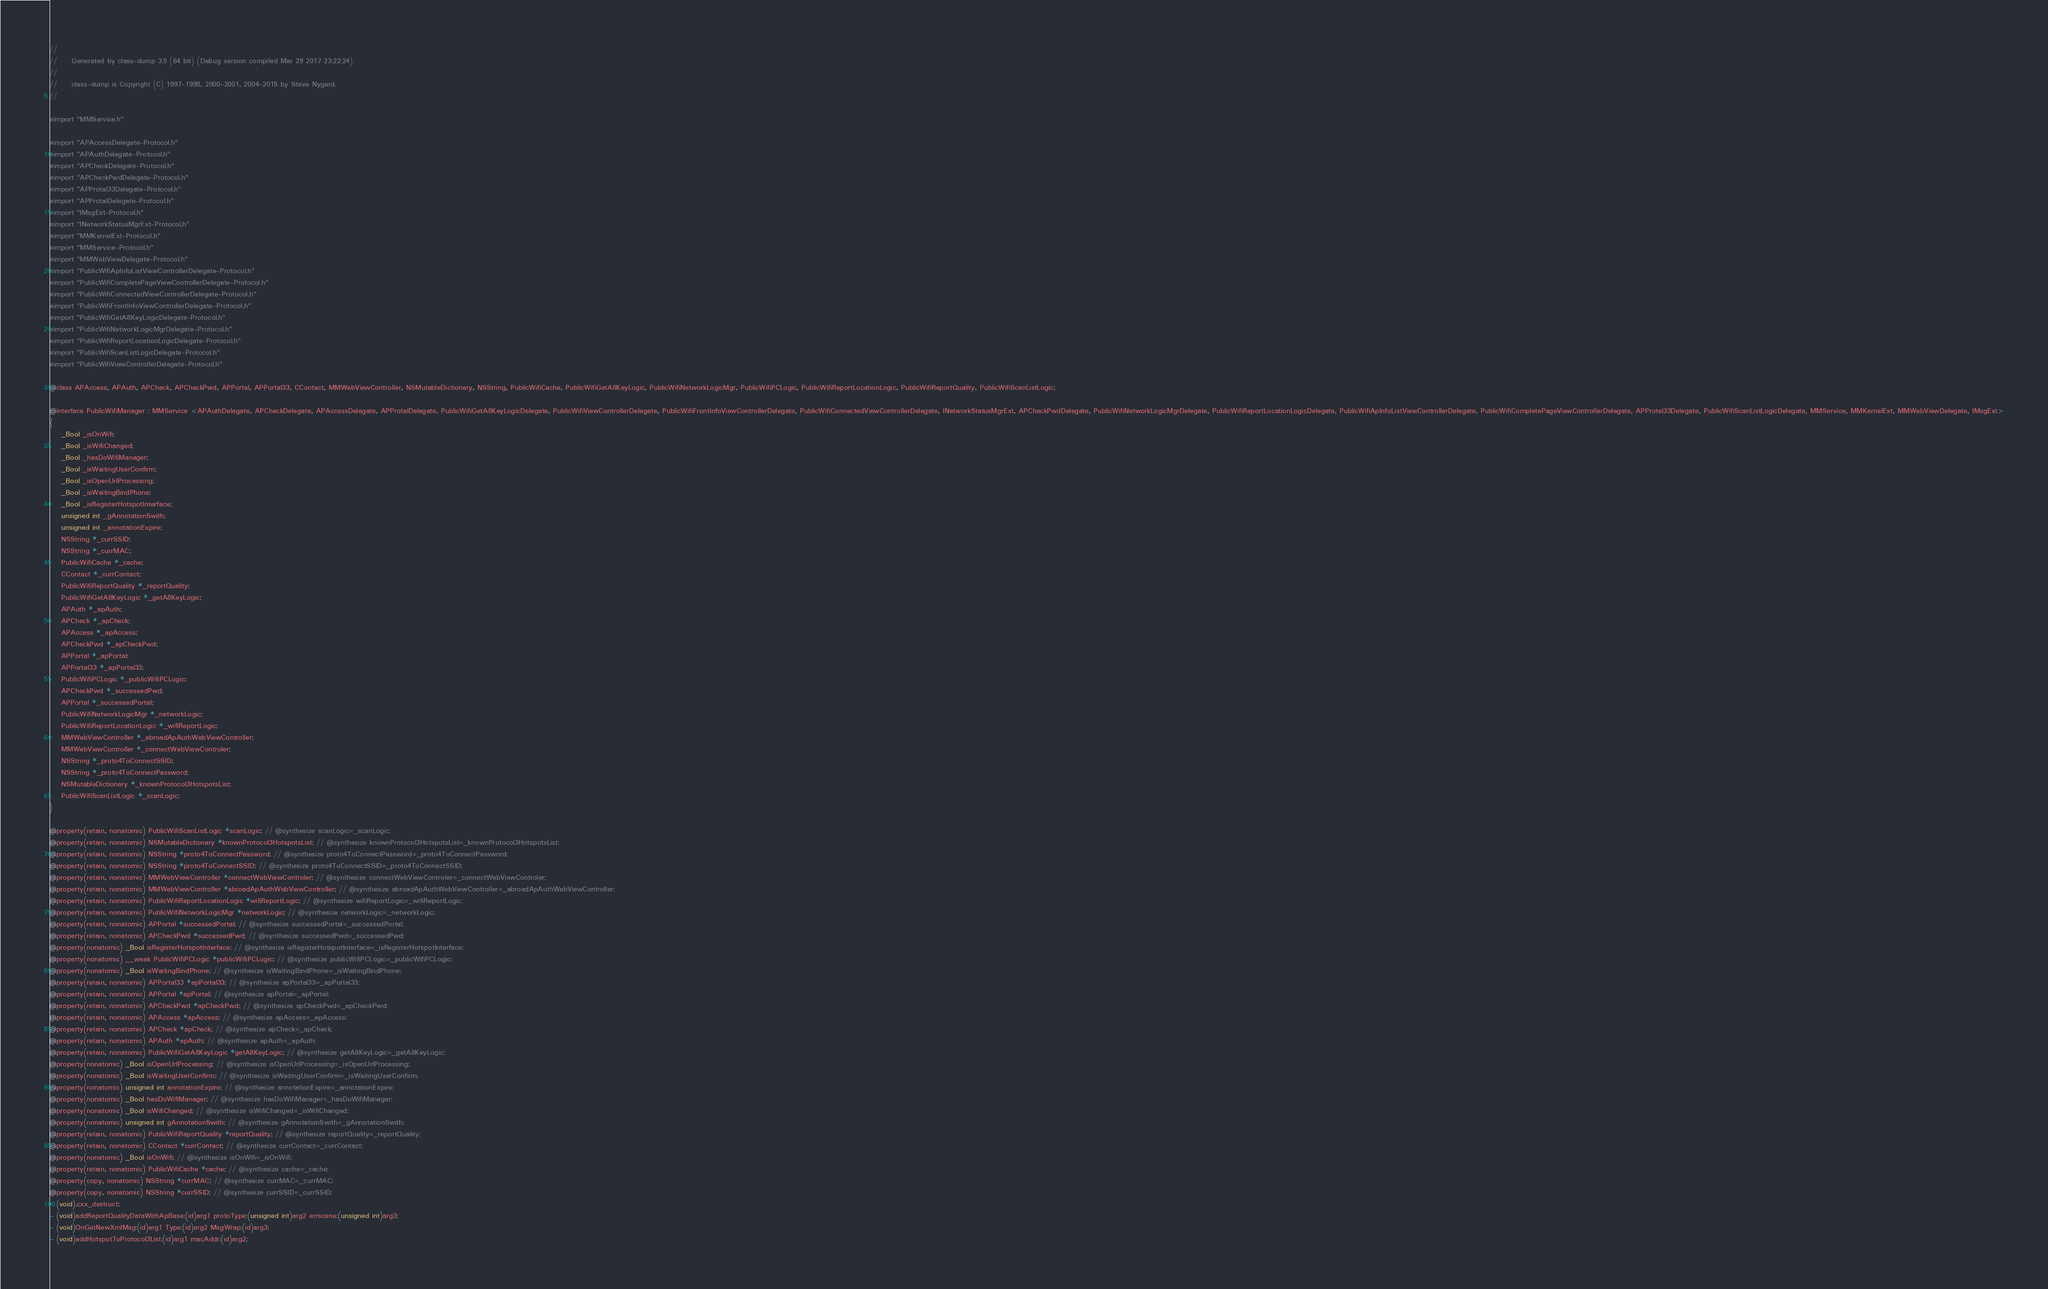<code> <loc_0><loc_0><loc_500><loc_500><_C_>//
//     Generated by class-dump 3.5 (64 bit) (Debug version compiled Mar 29 2017 23:22:24).
//
//     class-dump is Copyright (C) 1997-1998, 2000-2001, 2004-2015 by Steve Nygard.
//

#import "MMService.h"

#import "APAccessDelegate-Protocol.h"
#import "APAuthDelegate-Protocol.h"
#import "APCheckDelegate-Protocol.h"
#import "APCheckPwdDelegate-Protocol.h"
#import "APProtal33Delegate-Protocol.h"
#import "APProtalDelegate-Protocol.h"
#import "IMsgExt-Protocol.h"
#import "INetworkStatusMgrExt-Protocol.h"
#import "MMKernelExt-Protocol.h"
#import "MMService-Protocol.h"
#import "MMWebViewDelegate-Protocol.h"
#import "PublicWifiApInfoListViewControllerDelegate-Protocol.h"
#import "PublicWifiCompletePageViewControllerDelegate-Protocol.h"
#import "PublicWifiConnectedViewControllerDelegate-Protocol.h"
#import "PublicWifiFrontInfoViewControllerDelegate-Protocol.h"
#import "PublicWifiGetA8KeyLogicDelegate-Protocol.h"
#import "PublicWifiNetworkLogicMgrDelegate-Protocol.h"
#import "PublicWifiReportLocationLogicDelegate-Protocol.h"
#import "PublicWifiScanListLogicDelegate-Protocol.h"
#import "PublicWifiViewControllerDelegate-Protocol.h"

@class APAccess, APAuth, APCheck, APCheckPwd, APPortal, APPortal33, CContact, MMWebViewController, NSMutableDictionary, NSString, PublicWifiCache, PublicWifiGetA8KeyLogic, PublicWifiNetworkLogicMgr, PublicWifiPCLogic, PublicWifiReportLocationLogic, PublicWifiReportQuality, PublicWifiScanListLogic;

@interface PublicWifiManager : MMService <APAuthDelegate, APCheckDelegate, APAccessDelegate, APProtalDelegate, PublicWifiGetA8KeyLogicDelegate, PublicWifiViewControllerDelegate, PublicWifiFrontInfoViewControllerDelegate, PublicWifiConnectedViewControllerDelegate, INetworkStatusMgrExt, APCheckPwdDelegate, PublicWifiNetworkLogicMgrDelegate, PublicWifiReportLocationLogicDelegate, PublicWifiApInfoListViewControllerDelegate, PublicWifiCompletePageViewControllerDelegate, APProtal33Delegate, PublicWifiScanListLogicDelegate, MMService, MMKernelExt, MMWebViewDelegate, IMsgExt>
{
    _Bool _isOnWifi;
    _Bool _isWifiChanged;
    _Bool _hasDoWifiManager;
    _Bool _isWaitingUserConfirm;
    _Bool _isOpenUrlProcessing;
    _Bool _isWaitingBindPhone;
    _Bool _isRegisterHotspotInterface;
    unsigned int _gAnnotationSwith;
    unsigned int _annotationExpire;
    NSString *_currSSID;
    NSString *_currMAC;
    PublicWifiCache *_cache;
    CContact *_currContact;
    PublicWifiReportQuality *_reportQuality;
    PublicWifiGetA8KeyLogic *_getA8KeyLogic;
    APAuth *_apAuth;
    APCheck *_apCheck;
    APAccess *_apAccess;
    APCheckPwd *_apCheckPwd;
    APPortal *_apPortal;
    APPortal33 *_apPortal33;
    PublicWifiPCLogic *_publicWifiPCLogic;
    APCheckPwd *_successedPwd;
    APPortal *_successedPortal;
    PublicWifiNetworkLogicMgr *_networkLogic;
    PublicWifiReportLocationLogic *_wifiReportLogic;
    MMWebViewController *_abroadApAuthWebViewController;
    MMWebViewController *_connectWebViewControler;
    NSString *_proto4ToConnectSSID;
    NSString *_proto4ToConnectPassword;
    NSMutableDictionary *_knownProtocol3HotspotsList;
    PublicWifiScanListLogic *_scanLogic;
}

@property(retain, nonatomic) PublicWifiScanListLogic *scanLogic; // @synthesize scanLogic=_scanLogic;
@property(retain, nonatomic) NSMutableDictionary *knownProtocol3HotspotsList; // @synthesize knownProtocol3HotspotsList=_knownProtocol3HotspotsList;
@property(retain, nonatomic) NSString *proto4ToConnectPassword; // @synthesize proto4ToConnectPassword=_proto4ToConnectPassword;
@property(retain, nonatomic) NSString *proto4ToConnectSSID; // @synthesize proto4ToConnectSSID=_proto4ToConnectSSID;
@property(retain, nonatomic) MMWebViewController *connectWebViewControler; // @synthesize connectWebViewControler=_connectWebViewControler;
@property(retain, nonatomic) MMWebViewController *abroadApAuthWebViewController; // @synthesize abroadApAuthWebViewController=_abroadApAuthWebViewController;
@property(retain, nonatomic) PublicWifiReportLocationLogic *wifiReportLogic; // @synthesize wifiReportLogic=_wifiReportLogic;
@property(retain, nonatomic) PublicWifiNetworkLogicMgr *networkLogic; // @synthesize networkLogic=_networkLogic;
@property(retain, nonatomic) APPortal *successedPortal; // @synthesize successedPortal=_successedPortal;
@property(retain, nonatomic) APCheckPwd *successedPwd; // @synthesize successedPwd=_successedPwd;
@property(nonatomic) _Bool isRegisterHotspotInterface; // @synthesize isRegisterHotspotInterface=_isRegisterHotspotInterface;
@property(nonatomic) __weak PublicWifiPCLogic *publicWifiPCLogic; // @synthesize publicWifiPCLogic=_publicWifiPCLogic;
@property(nonatomic) _Bool isWaitingBindPhone; // @synthesize isWaitingBindPhone=_isWaitingBindPhone;
@property(retain, nonatomic) APPortal33 *apPortal33; // @synthesize apPortal33=_apPortal33;
@property(retain, nonatomic) APPortal *apPortal; // @synthesize apPortal=_apPortal;
@property(retain, nonatomic) APCheckPwd *apCheckPwd; // @synthesize apCheckPwd=_apCheckPwd;
@property(retain, nonatomic) APAccess *apAccess; // @synthesize apAccess=_apAccess;
@property(retain, nonatomic) APCheck *apCheck; // @synthesize apCheck=_apCheck;
@property(retain, nonatomic) APAuth *apAuth; // @synthesize apAuth=_apAuth;
@property(retain, nonatomic) PublicWifiGetA8KeyLogic *getA8KeyLogic; // @synthesize getA8KeyLogic=_getA8KeyLogic;
@property(nonatomic) _Bool isOpenUrlProcessing; // @synthesize isOpenUrlProcessing=_isOpenUrlProcessing;
@property(nonatomic) _Bool isWaitingUserConfirm; // @synthesize isWaitingUserConfirm=_isWaitingUserConfirm;
@property(nonatomic) unsigned int annotationExpire; // @synthesize annotationExpire=_annotationExpire;
@property(nonatomic) _Bool hasDoWifiManager; // @synthesize hasDoWifiManager=_hasDoWifiManager;
@property(nonatomic) _Bool isWifiChanged; // @synthesize isWifiChanged=_isWifiChanged;
@property(nonatomic) unsigned int gAnnotationSwith; // @synthesize gAnnotationSwith=_gAnnotationSwith;
@property(retain, nonatomic) PublicWifiReportQuality *reportQuality; // @synthesize reportQuality=_reportQuality;
@property(retain, nonatomic) CContact *currContact; // @synthesize currContact=_currContact;
@property(nonatomic) _Bool isOnWifi; // @synthesize isOnWifi=_isOnWifi;
@property(retain, nonatomic) PublicWifiCache *cache; // @synthesize cache=_cache;
@property(copy, nonatomic) NSString *currMAC; // @synthesize currMAC=_currMAC;
@property(copy, nonatomic) NSString *currSSID; // @synthesize currSSID=_currSSID;
- (void).cxx_destruct;
- (void)addReportQualityDataWithApBase:(id)arg1 protoType:(unsigned int)arg2 errscene:(unsigned int)arg3;
- (void)OnGetNewXmlMsg:(id)arg1 Type:(id)arg2 MsgWrap:(id)arg3;
- (void)addHotspotToProtocol3List:(id)arg1 macAddr:(id)arg2;</code> 